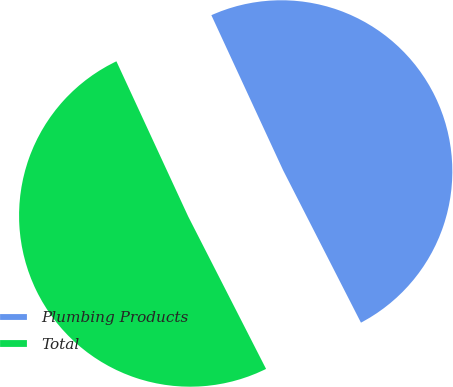Convert chart. <chart><loc_0><loc_0><loc_500><loc_500><pie_chart><fcel>Plumbing Products<fcel>Total<nl><fcel>49.38%<fcel>50.62%<nl></chart> 